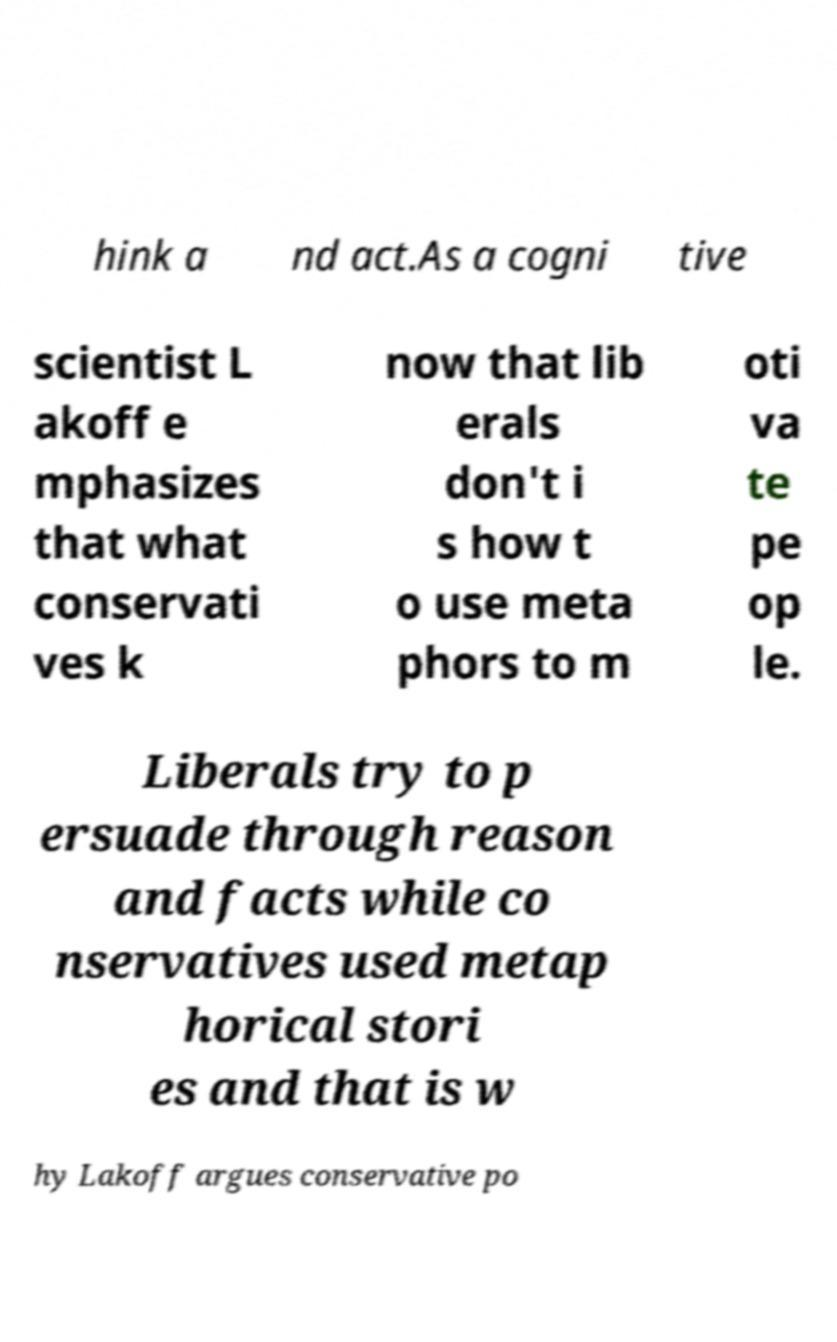Could you extract and type out the text from this image? hink a nd act.As a cogni tive scientist L akoff e mphasizes that what conservati ves k now that lib erals don't i s how t o use meta phors to m oti va te pe op le. Liberals try to p ersuade through reason and facts while co nservatives used metap horical stori es and that is w hy Lakoff argues conservative po 